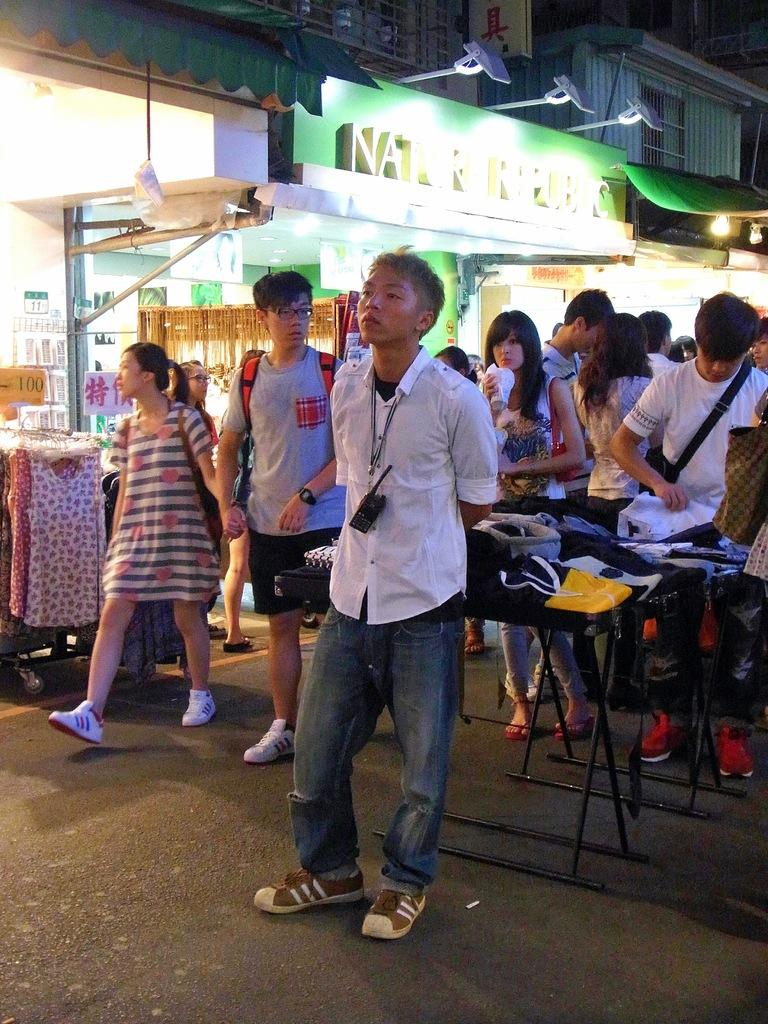What is happening on the road in the image? There are people on the road in the image. What type of items can be seen on the tables in the image? There are tablecloths in the image. What type of signage is present in the image? There are posters and boards in the image. What type of illumination is present in the image? There are lights in the image. What type of structures are visible in the image? There are buildings in the image. Can you tell me how many cords are attached to the lights in the image? There is no mention of cords in the image; the lights are present, but their source of power is not visible. What type of park is visible in the image? There is no park present in the image; it features people, tablecloths, posters, boards, lights, and buildings. 